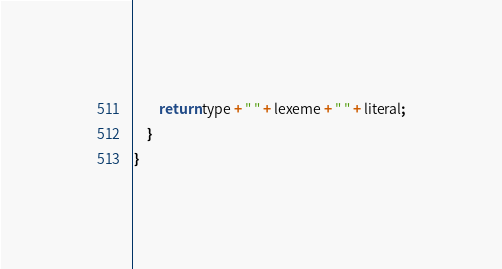<code> <loc_0><loc_0><loc_500><loc_500><_Java_>		return type + " " + lexeme + " " + literal;
	}
}
</code> 